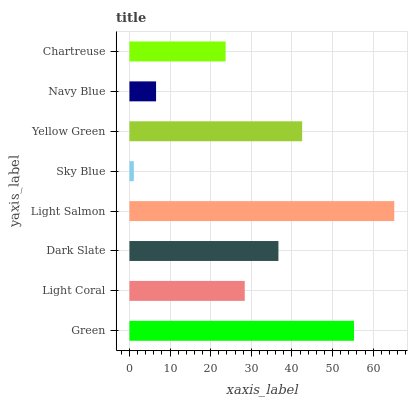Is Sky Blue the minimum?
Answer yes or no. Yes. Is Light Salmon the maximum?
Answer yes or no. Yes. Is Light Coral the minimum?
Answer yes or no. No. Is Light Coral the maximum?
Answer yes or no. No. Is Green greater than Light Coral?
Answer yes or no. Yes. Is Light Coral less than Green?
Answer yes or no. Yes. Is Light Coral greater than Green?
Answer yes or no. No. Is Green less than Light Coral?
Answer yes or no. No. Is Dark Slate the high median?
Answer yes or no. Yes. Is Light Coral the low median?
Answer yes or no. Yes. Is Sky Blue the high median?
Answer yes or no. No. Is Dark Slate the low median?
Answer yes or no. No. 